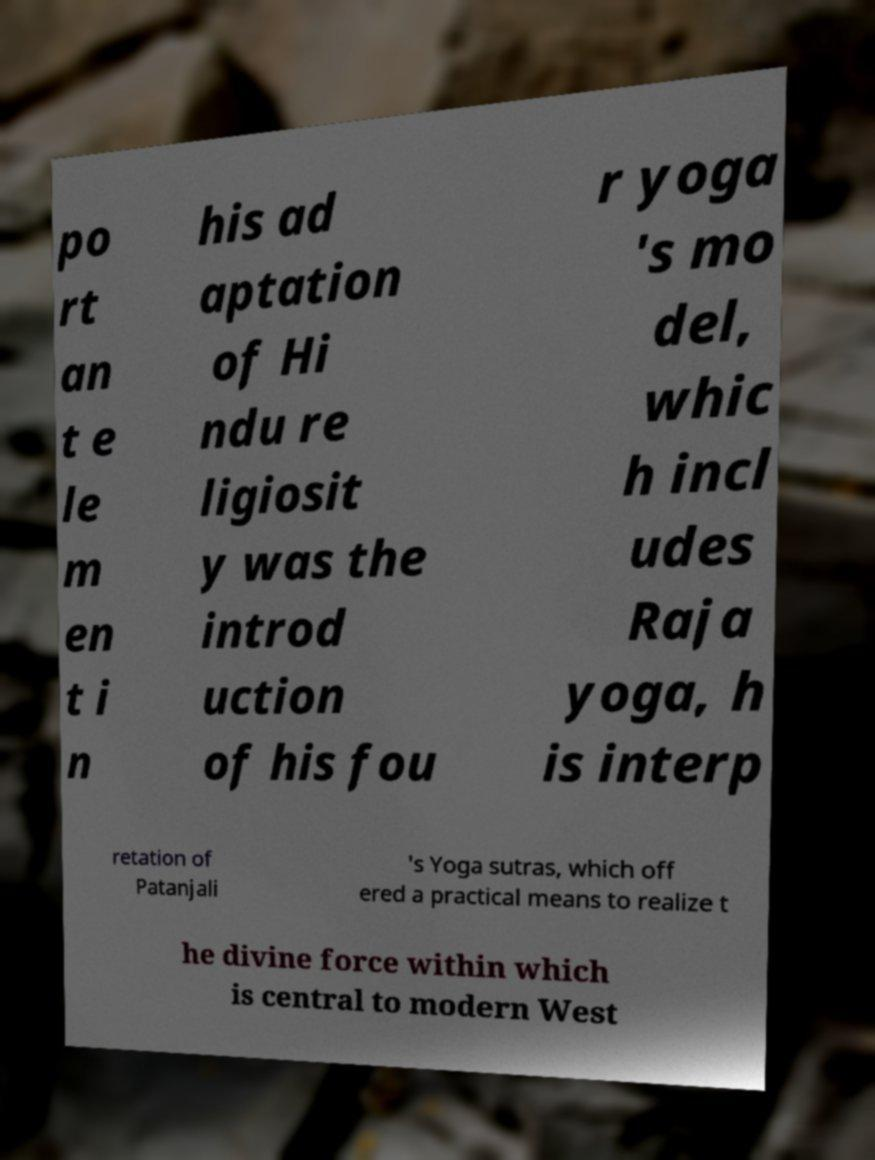Please read and relay the text visible in this image. What does it say? po rt an t e le m en t i n his ad aptation of Hi ndu re ligiosit y was the introd uction of his fou r yoga 's mo del, whic h incl udes Raja yoga, h is interp retation of Patanjali 's Yoga sutras, which off ered a practical means to realize t he divine force within which is central to modern West 